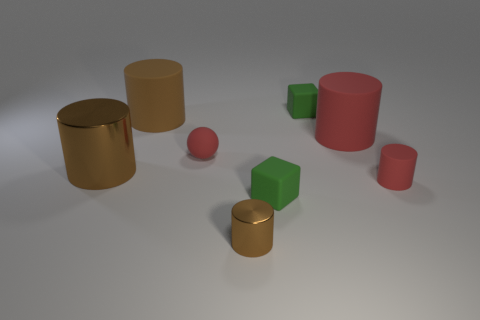There is a rubber thing that is the same color as the tiny metallic cylinder; what size is it?
Offer a very short reply. Large. Is the color of the big metallic cylinder the same as the tiny metal thing?
Provide a succinct answer. Yes. There is a green matte block in front of the tiny matte cylinder; are there any things on the left side of it?
Give a very brief answer. Yes. How many things are either small matte spheres that are right of the brown rubber cylinder or tiny green things?
Make the answer very short. 3. How many metal cylinders are there?
Your answer should be very brief. 2. What shape is the big brown object that is the same material as the large red thing?
Provide a short and direct response. Cylinder. There is a red matte cylinder that is behind the metallic thing on the left side of the tiny brown shiny cylinder; how big is it?
Offer a very short reply. Large. How many things are tiny things left of the tiny brown metallic cylinder or small things that are on the right side of the tiny metallic cylinder?
Provide a succinct answer. 4. Are there fewer tiny brown metallic cylinders than red matte things?
Give a very brief answer. Yes. What number of objects are either small green blocks or small purple things?
Keep it short and to the point. 2. 